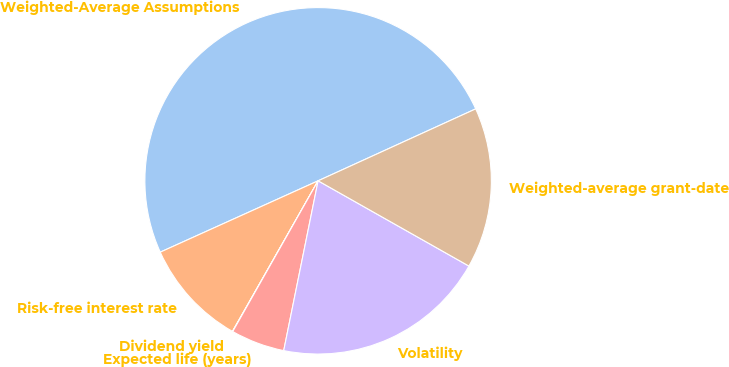<chart> <loc_0><loc_0><loc_500><loc_500><pie_chart><fcel>Weighted-Average Assumptions<fcel>Risk-free interest rate<fcel>Dividend yield<fcel>Expected life (years)<fcel>Volatility<fcel>Weighted-average grant-date<nl><fcel>49.93%<fcel>10.01%<fcel>0.03%<fcel>5.02%<fcel>19.99%<fcel>15.0%<nl></chart> 